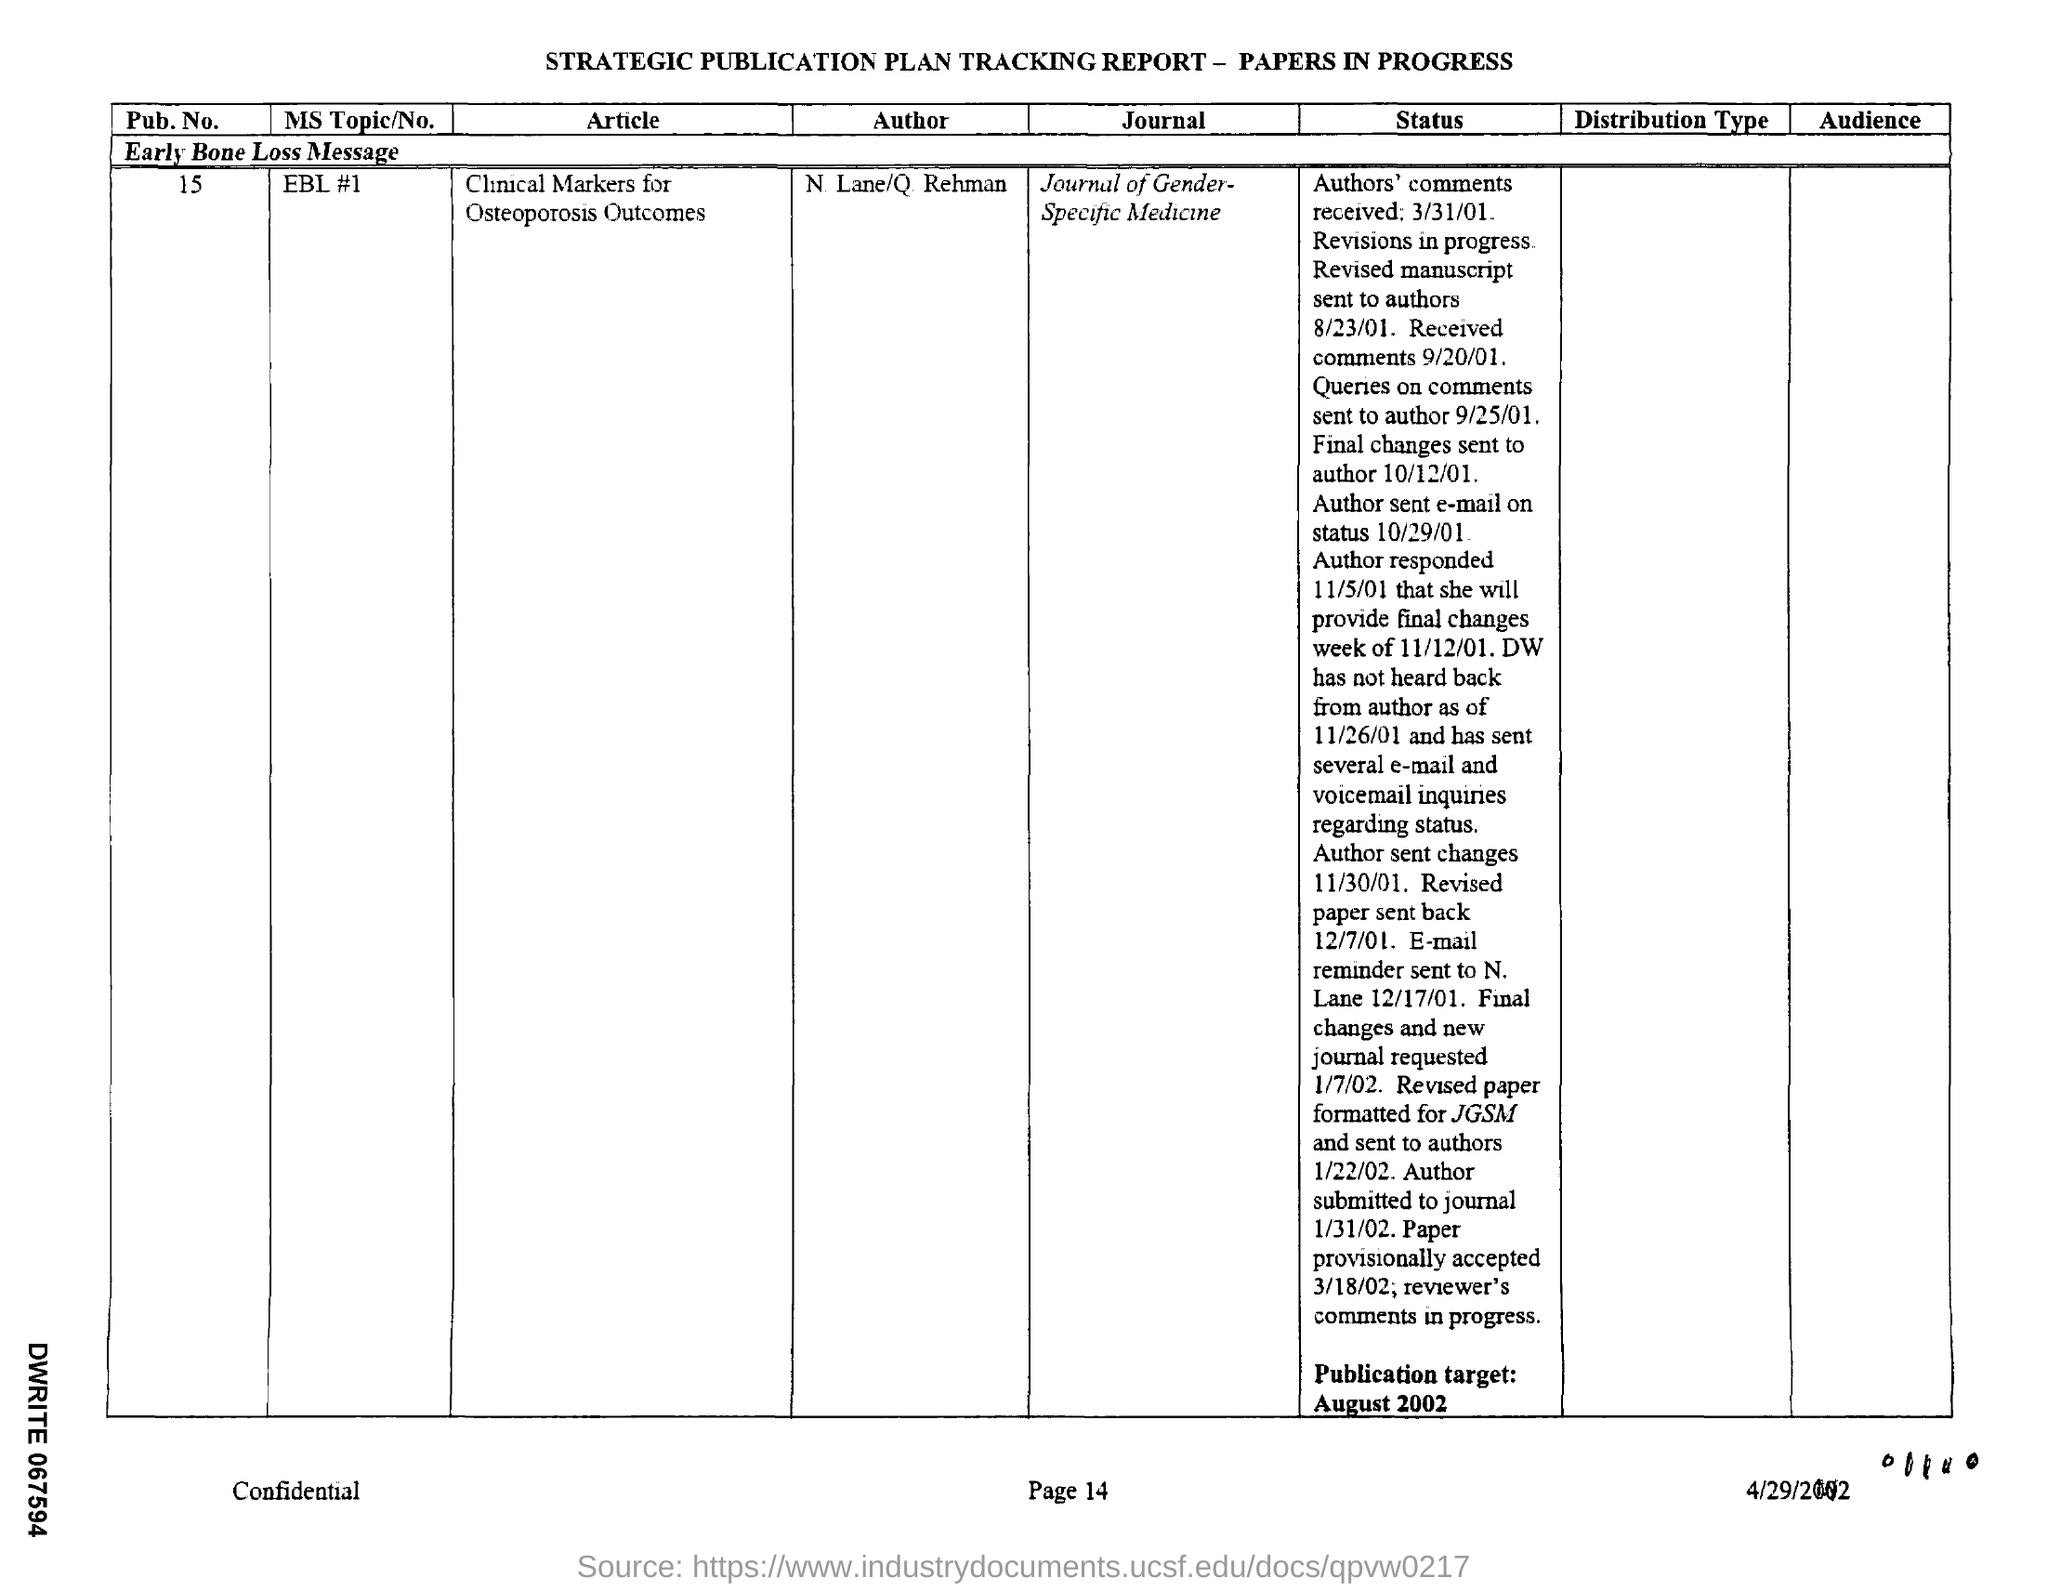Specify some key components in this picture. The MS Topic was not mentioned in the given report, and EBL #1 was mentioned. The report mentions a pub.no. of 15.. 